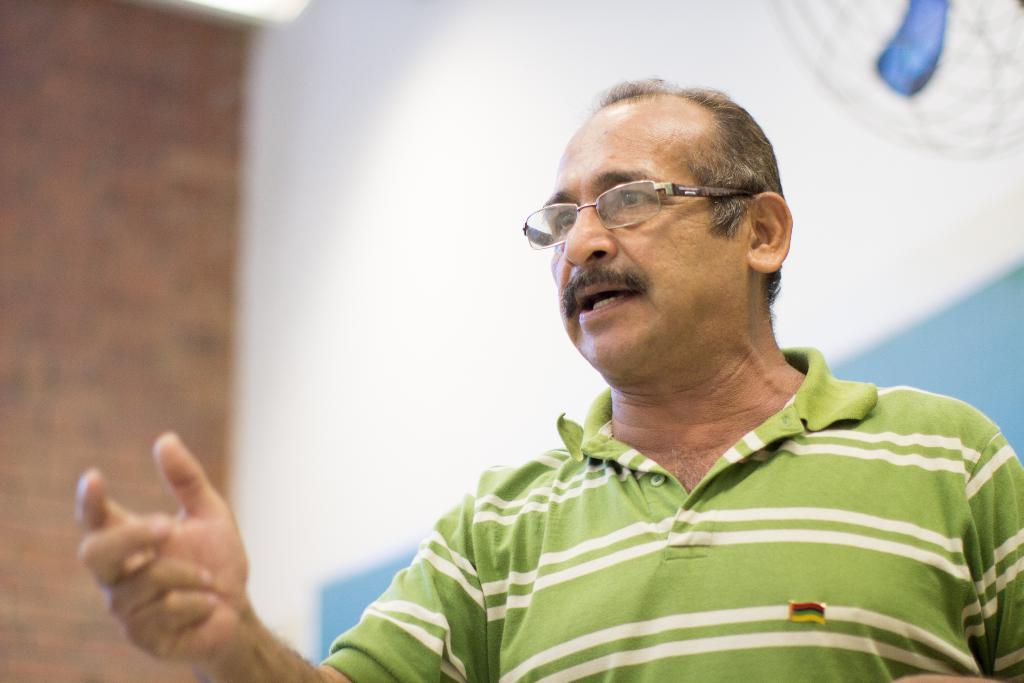What is the main subject of the image? There is a person in the center of the image. What can be seen in the background of the image? There is a wall in the background of the image. Can you see a seashore in the image? No, there is no seashore present in the image. What type of playground equipment can be seen in the image? There is no playground equipment present in the image. 